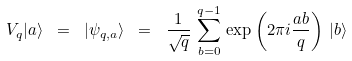Convert formula to latex. <formula><loc_0><loc_0><loc_500><loc_500>V _ { q } | a \rangle \ = \ | \psi _ { q , a } \rangle \ = \ \frac { 1 } { \sqrt { q } } \, \sum _ { b = 0 } ^ { q - 1 } \, \exp \left ( 2 \pi i \frac { a b } { q } \right ) \, | b \rangle</formula> 